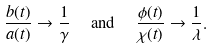<formula> <loc_0><loc_0><loc_500><loc_500>& \frac { b ( t ) } { a ( t ) } \to \frac { 1 } { \gamma } \quad \text { and } \quad \frac { \phi ( t ) } { \chi ( t ) } \to \frac { 1 } { \lambda } .</formula> 